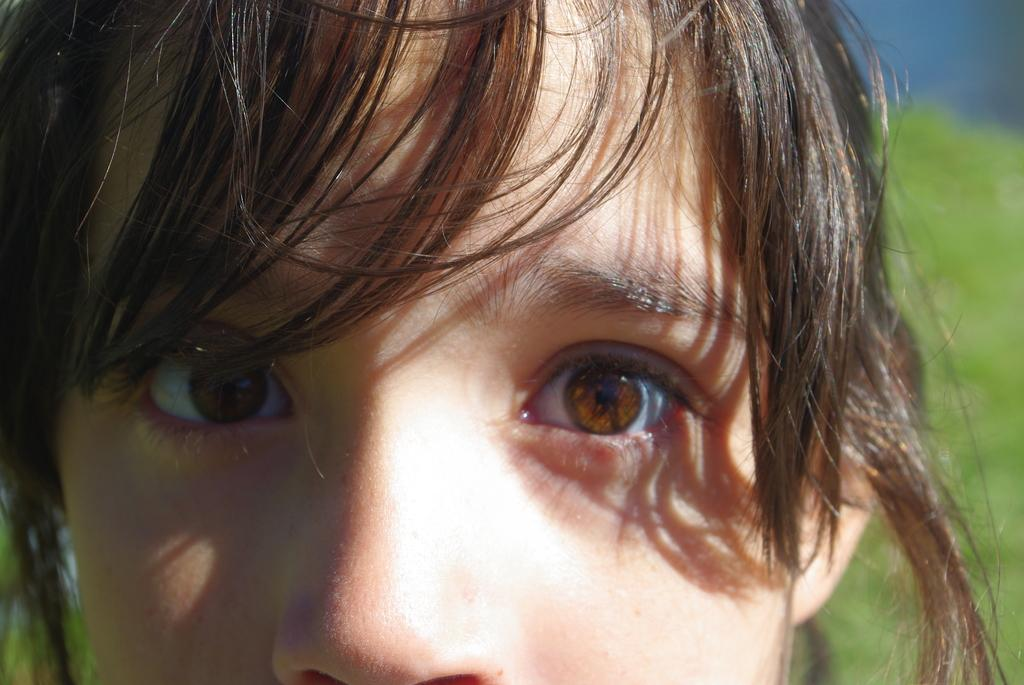What is the main subject of the image? There is a person's face in the image. Can you describe the background of the image? The background of the image is blurred. How many snakes are wrapped around the person's face in the image? There are no snakes present in the image; it only features a person's face. What type of produce can be seen in the image? There is no produce present in the image; it only features a person's face. 